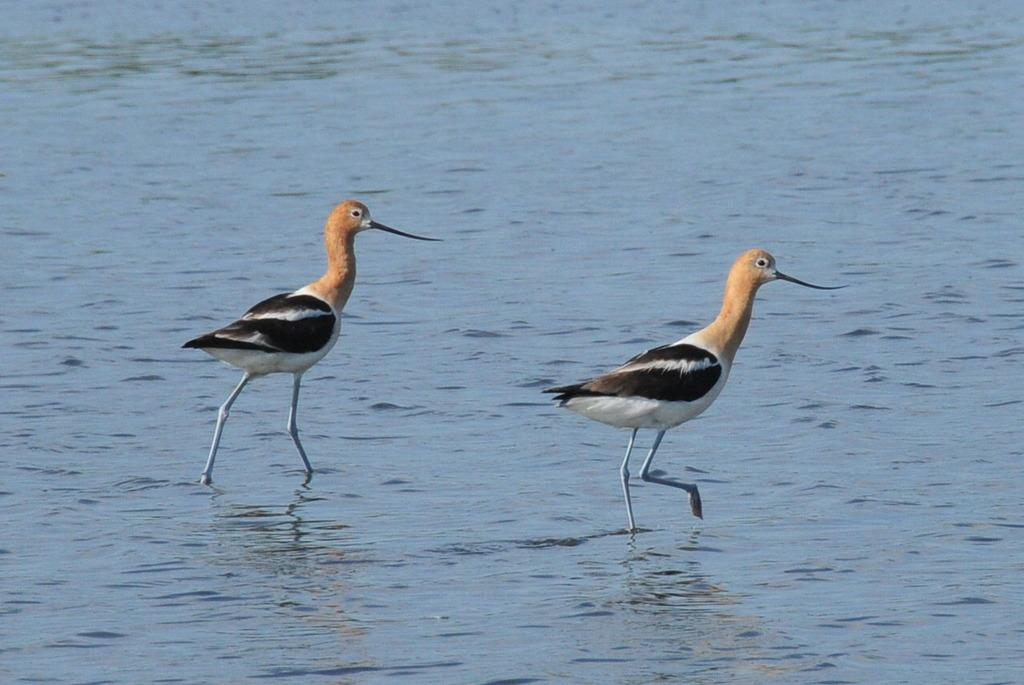What are the main subjects in the center of the image? There are two cranes in the center of the image. What is located at the bottom of the image? There is a river at the bottom of the image. What type of bait is being used by the cranes in the image? There is no bait present in the image, as cranes typically do not use bait to catch their food. 